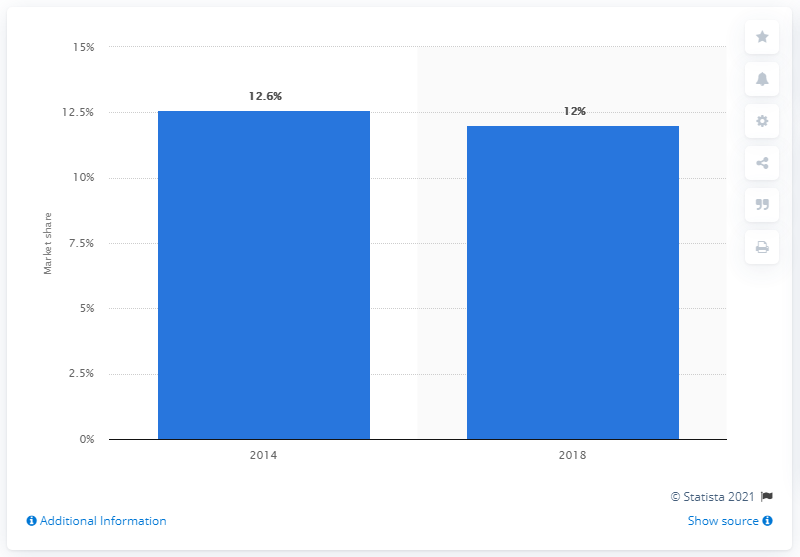List a handful of essential elements in this visual. In 2018, FCA's market share in the United States was 12%. 